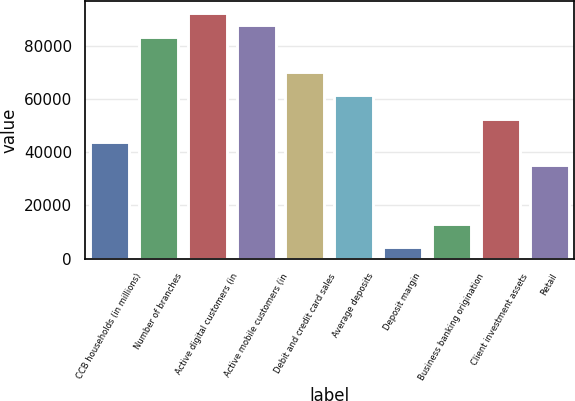Convert chart to OTSL. <chart><loc_0><loc_0><loc_500><loc_500><bar_chart><fcel>CCB households (in millions)<fcel>Number of branches<fcel>Active digital customers (in<fcel>Active mobile customers (in<fcel>Debit and credit card sales<fcel>Average deposits<fcel>Deposit margin<fcel>Business banking origination<fcel>Client investment assets<fcel>Retail<nl><fcel>43836<fcel>83287.5<fcel>92054.5<fcel>87671<fcel>70137<fcel>61370<fcel>4384.53<fcel>13151.5<fcel>52603<fcel>35069<nl></chart> 